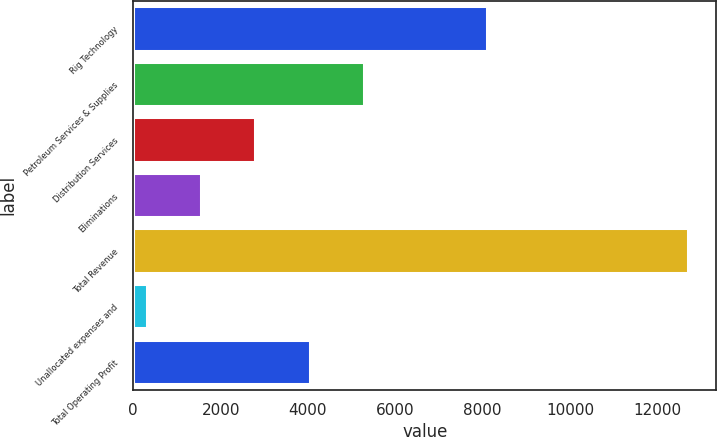Convert chart. <chart><loc_0><loc_0><loc_500><loc_500><bar_chart><fcel>Rig Technology<fcel>Petroleum Services & Supplies<fcel>Distribution Services<fcel>Eliminations<fcel>Total Revenue<fcel>Unallocated expenses and<fcel>Total Operating Profit<nl><fcel>8093<fcel>5276.2<fcel>2797.6<fcel>1558.3<fcel>12712<fcel>319<fcel>4036.9<nl></chart> 